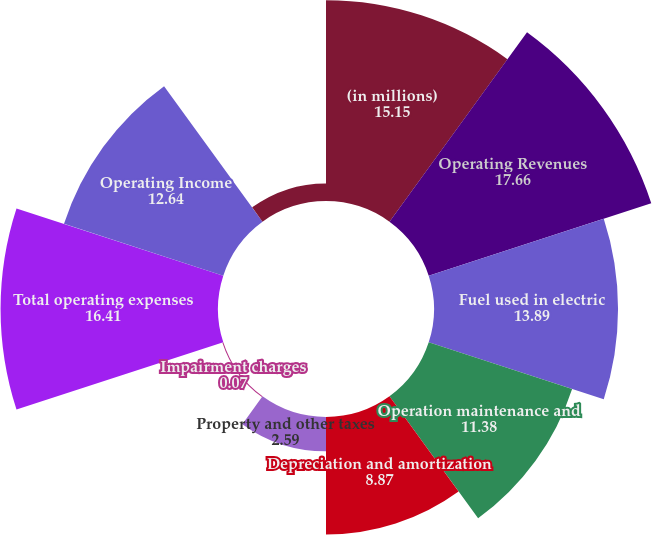Convert chart to OTSL. <chart><loc_0><loc_0><loc_500><loc_500><pie_chart><fcel>(in millions)<fcel>Operating Revenues<fcel>Fuel used in electric<fcel>Operation maintenance and<fcel>Depreciation and amortization<fcel>Property and other taxes<fcel>Impairment charges<fcel>Total operating expenses<fcel>Operating Income<fcel>Other Income and Expenses net<nl><fcel>15.15%<fcel>17.66%<fcel>13.89%<fcel>11.38%<fcel>8.87%<fcel>2.59%<fcel>0.07%<fcel>16.41%<fcel>12.64%<fcel>1.33%<nl></chart> 